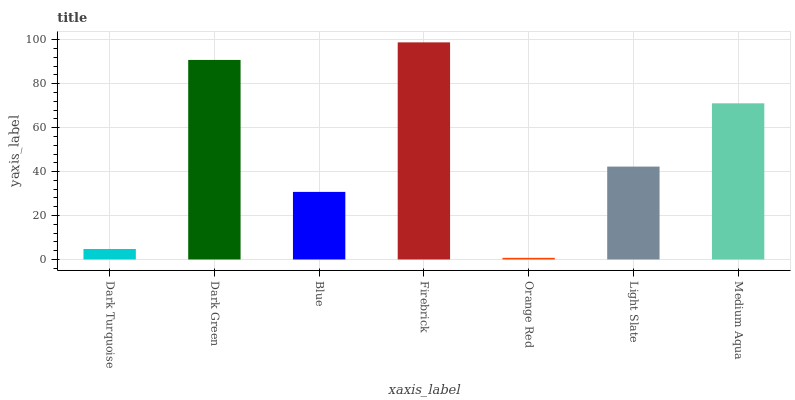Is Orange Red the minimum?
Answer yes or no. Yes. Is Firebrick the maximum?
Answer yes or no. Yes. Is Dark Green the minimum?
Answer yes or no. No. Is Dark Green the maximum?
Answer yes or no. No. Is Dark Green greater than Dark Turquoise?
Answer yes or no. Yes. Is Dark Turquoise less than Dark Green?
Answer yes or no. Yes. Is Dark Turquoise greater than Dark Green?
Answer yes or no. No. Is Dark Green less than Dark Turquoise?
Answer yes or no. No. Is Light Slate the high median?
Answer yes or no. Yes. Is Light Slate the low median?
Answer yes or no. Yes. Is Blue the high median?
Answer yes or no. No. Is Dark Turquoise the low median?
Answer yes or no. No. 